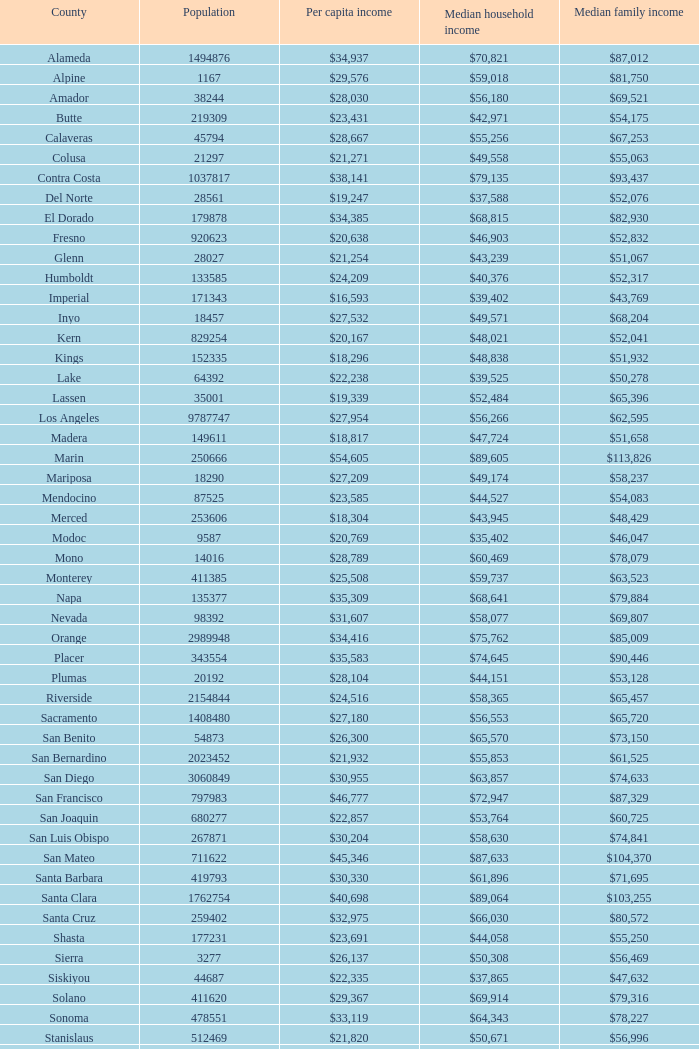What is the per capita income of shasta? $23,691. 